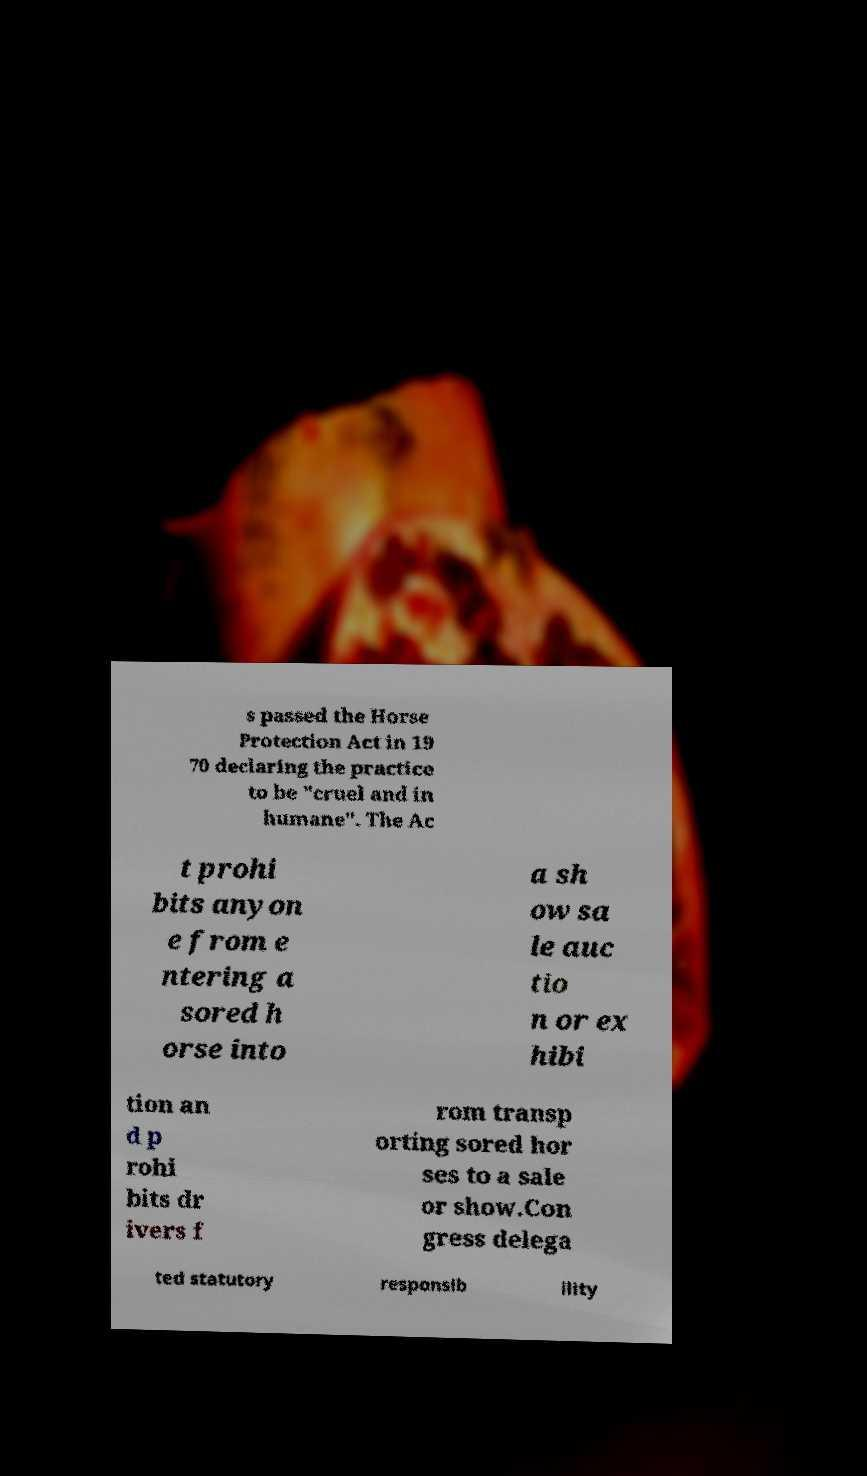Can you read and provide the text displayed in the image?This photo seems to have some interesting text. Can you extract and type it out for me? s passed the Horse Protection Act in 19 70 declaring the practice to be "cruel and in humane". The Ac t prohi bits anyon e from e ntering a sored h orse into a sh ow sa le auc tio n or ex hibi tion an d p rohi bits dr ivers f rom transp orting sored hor ses to a sale or show.Con gress delega ted statutory responsib ility 